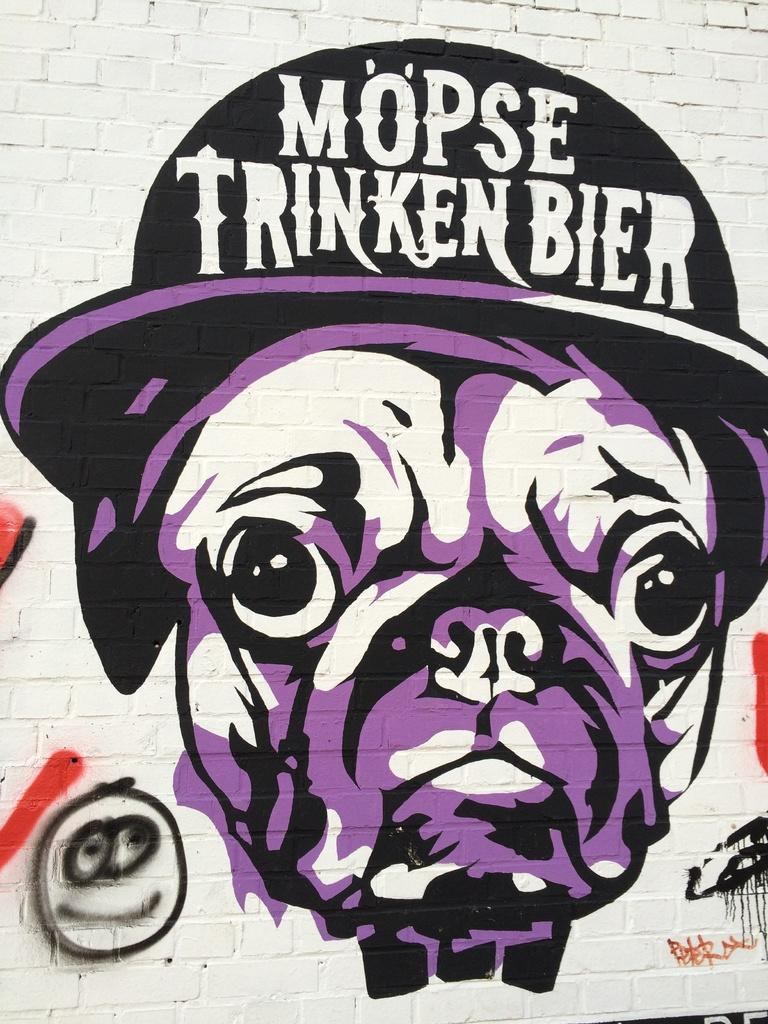What is the main subject in the foreground of the image? There are graffiti paintings on a wall in the foreground of the image. Can you describe the graffiti paintings? Unfortunately, the details of the graffiti paintings cannot be determined from the image alone. What is the background of the image? The background of the image is not mentioned in the provided facts, so it cannot be described. What is the value of the hand-painted verse on the wall in the image? There is no hand-painted verse mentioned in the image, only graffiti paintings on a wall. 